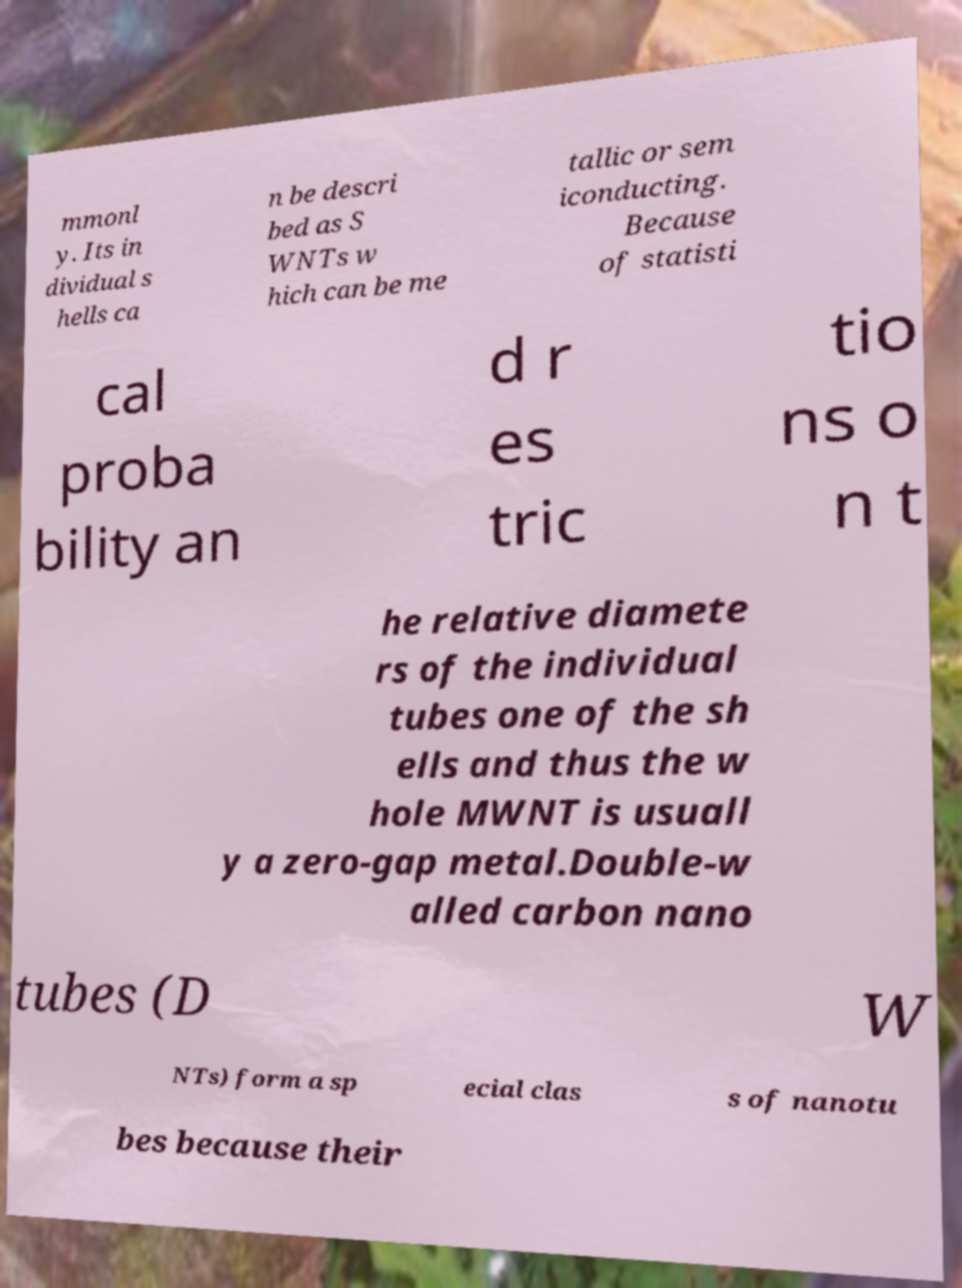Please read and relay the text visible in this image. What does it say? mmonl y. Its in dividual s hells ca n be descri bed as S WNTs w hich can be me tallic or sem iconducting. Because of statisti cal proba bility an d r es tric tio ns o n t he relative diamete rs of the individual tubes one of the sh ells and thus the w hole MWNT is usuall y a zero-gap metal.Double-w alled carbon nano tubes (D W NTs) form a sp ecial clas s of nanotu bes because their 